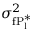<formula> <loc_0><loc_0><loc_500><loc_500>\sigma _ { f P _ { l } ^ { * } } ^ { 2 }</formula> 